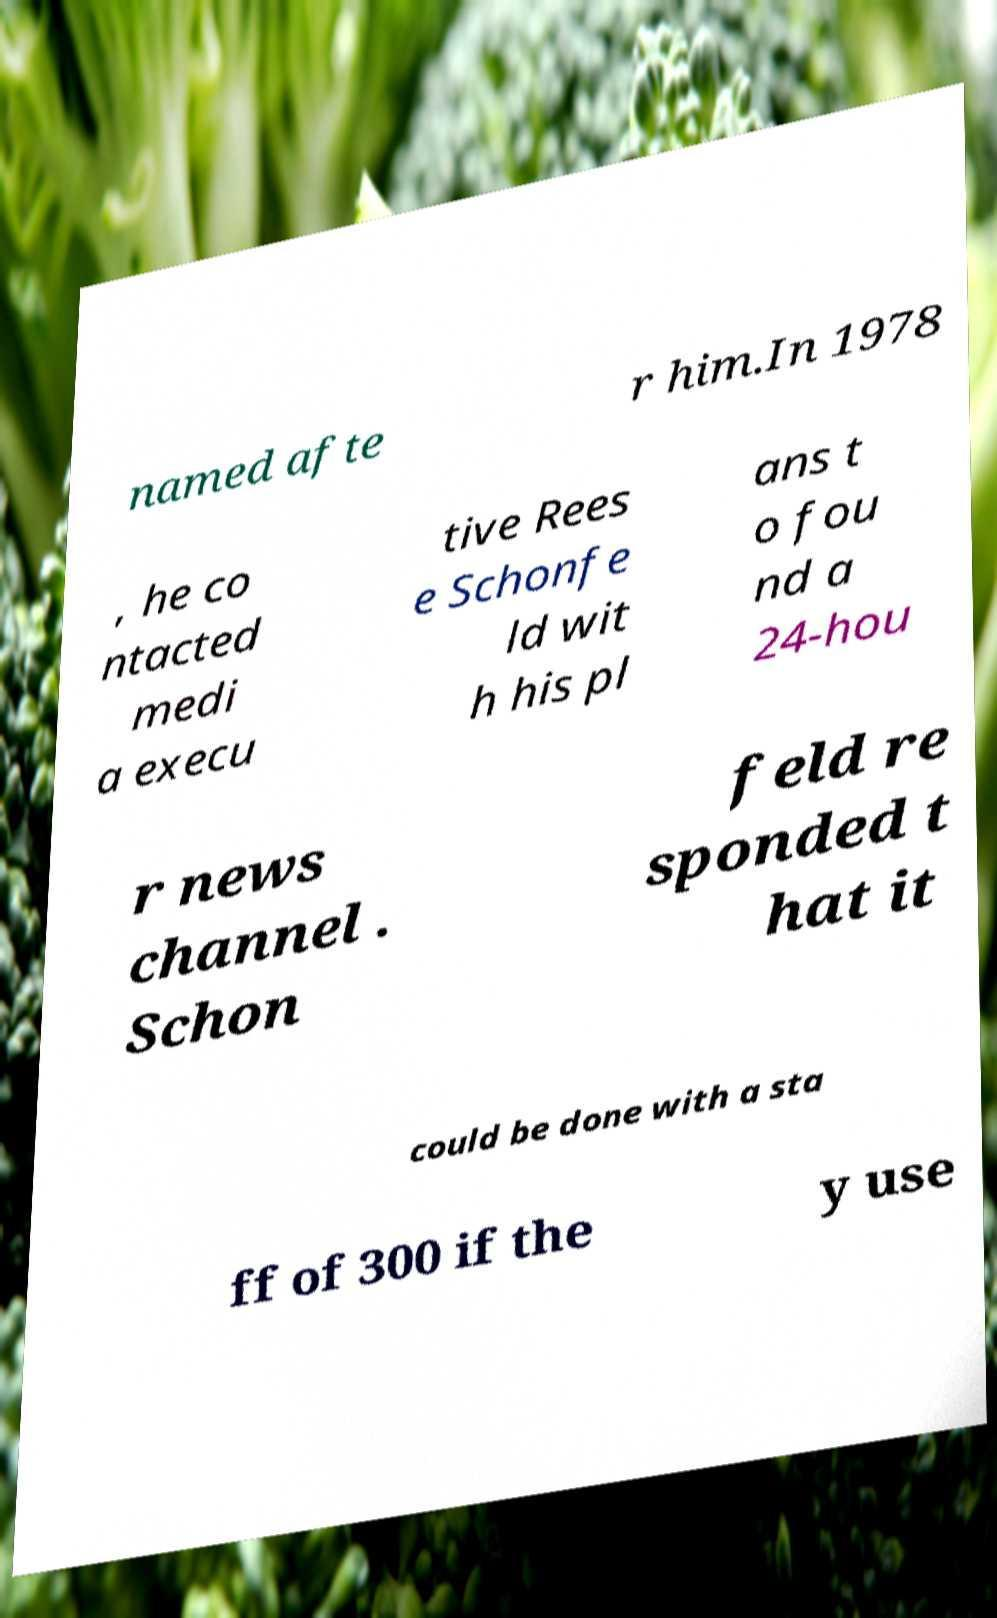For documentation purposes, I need the text within this image transcribed. Could you provide that? named afte r him.In 1978 , he co ntacted medi a execu tive Rees e Schonfe ld wit h his pl ans t o fou nd a 24-hou r news channel . Schon feld re sponded t hat it could be done with a sta ff of 300 if the y use 